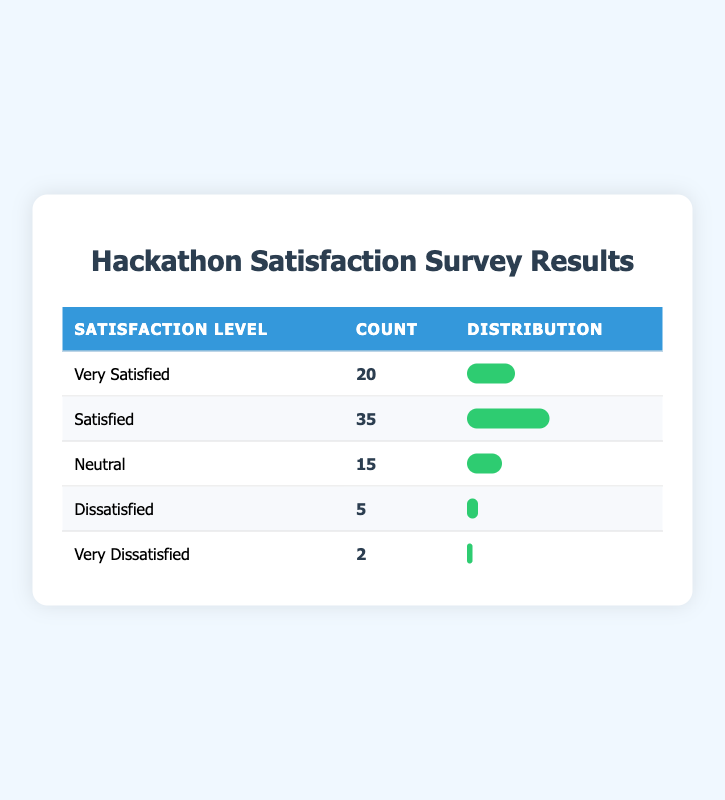What is the total number of participants surveyed? To find the total number of participants surveyed, we need to sum all the counts in the table: 20 + 35 + 15 + 5 + 2 = 77.
Answer: 77 How many participants were "Dissatisfied"? The count for "Dissatisfied" in the table shows a value of 5.
Answer: 5 What percentage of participants reported being "Very Satisfied"? The count of participants who are "Very Satisfied" is 20, and the total participants are 77. The percentage is calculated as (20 / 77) * 100 ≈ 26%.
Answer: 26% Is the number of participants who are "Neutral" greater than those who are "Dissatisfied"? The count for "Neutral" is 15, and for "Dissatisfied" it is 5. Since 15 is greater than 5, the statement is true.
Answer: Yes What is the difference in count between "Satisfied" and "Very Satisfied"? The count for "Satisfied" is 35, and for "Very Satisfied" it is 20. The difference is 35 - 20 = 15.
Answer: 15 What is the average satisfaction level of all participants on the scale of 1 to 5 (1 being "Very Dissatisfied" and 5 being "Very Satisfied")? The average can be calculated by assigning values: Very Satisfied = 5, Satisfied = 4, Neutral = 3, Dissatisfied = 2, Very Dissatisfied = 1. Counting the total participants gives us (20*5 + 35*4 + 15*3 + 5*2 + 2*1) / 77 = 3.54.
Answer: 3.54 How many participants rated their satisfaction level as either "Very Satisfied" or "Satisfied"? "Very Satisfied" has a count of 20 and "Satisfied" has 35. Adding these gives us 20 + 35 = 55.
Answer: 55 Which satisfaction level has the highest count and what is that count? "Satisfied" has the highest count with 35 participants.
Answer: Satisfied, 35 